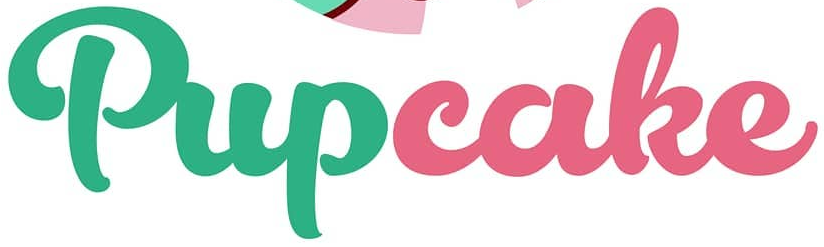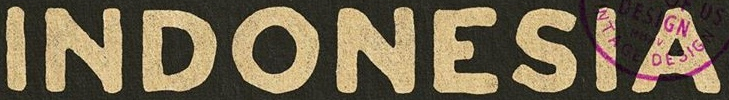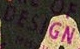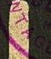What words are shown in these images in order, separated by a semicolon? Pupcake; INDONESIA; DESIGN; NTAG 